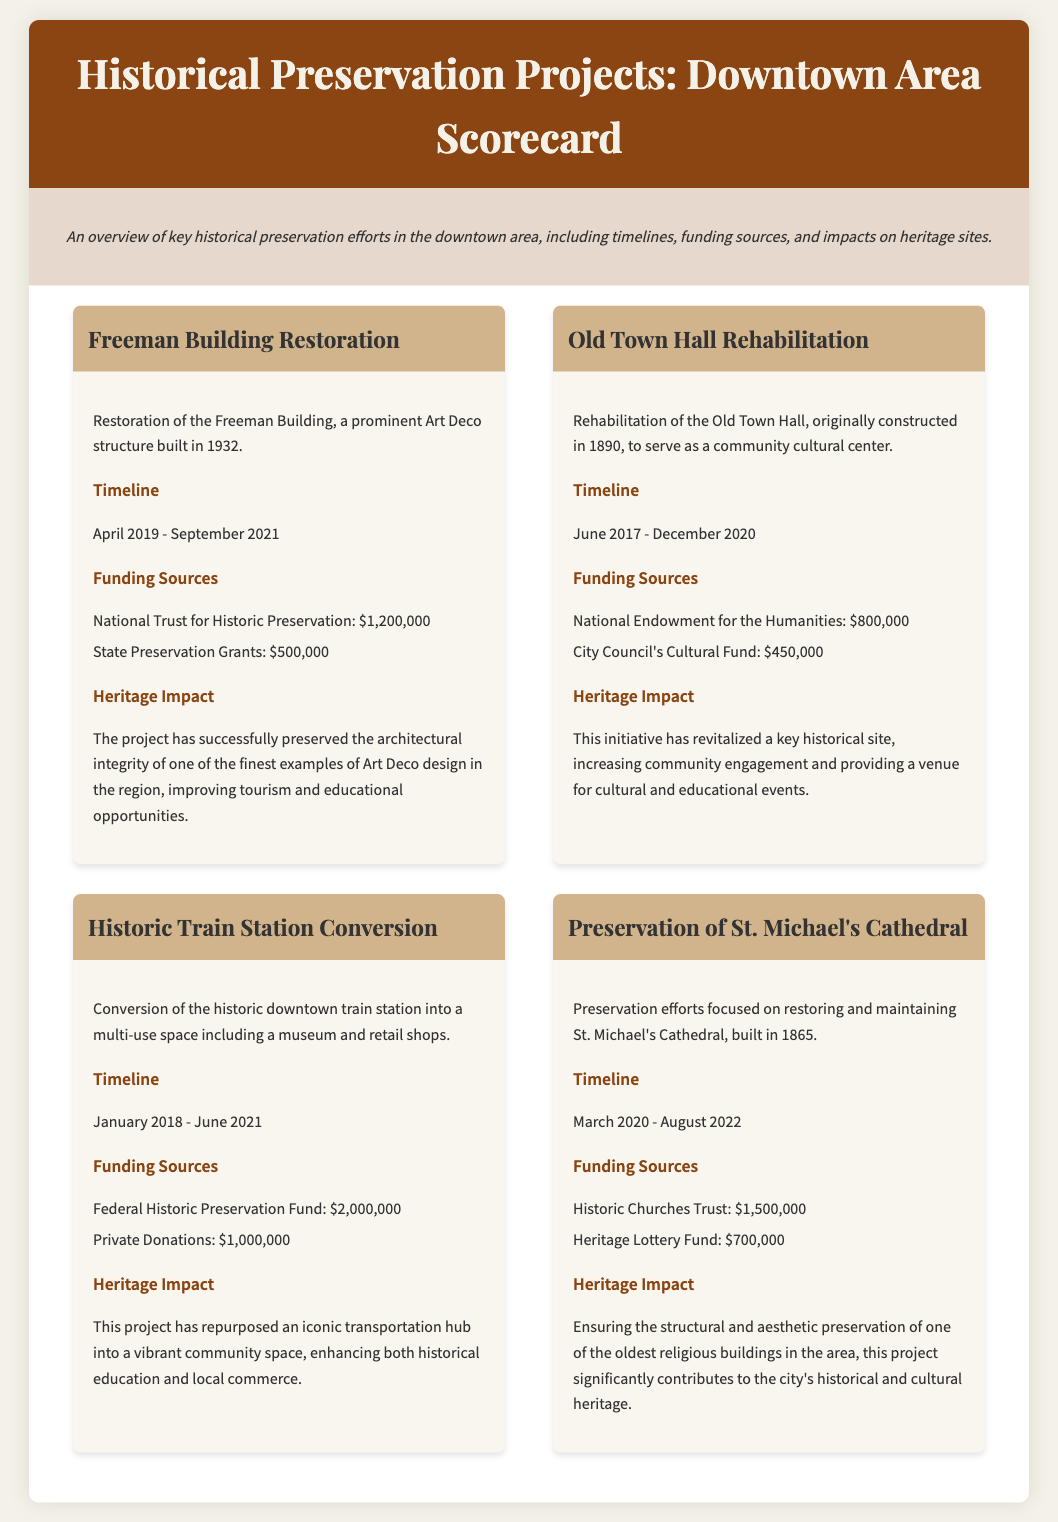What is the funding from the National Trust for Historic Preservation for the Freeman Building Restoration? The document states that the funding from the National Trust for Historic Preservation for the Freeman Building Restoration is $1,200,000.
Answer: $1,200,000 What year was the Old Town Hall originally constructed? According to the document, the Old Town Hall was originally constructed in 1890.
Answer: 1890 When did the preservation efforts for St. Michael's Cathedral start? The document indicates that the preservation efforts for St. Michael's Cathedral began in March 2020.
Answer: March 2020 What is the total funding amount for the Historic Train Station Conversion? The total funding for the Historic Train Station Conversion is the sum of Federal Historic Preservation Fund and Private Donations: $2,000,000 + $1,000,000 = $3,000,000.
Answer: $3,000,000 What heritage impact is attributed to the Old Town Hall rehabilitation? The impact states that the initiative has revitalized a key historical site, increasing community engagement and providing a venue for cultural and educational events.
Answer: Increased community engagement What structure was restored as part of the Freeman Building project? The Freeman Building project involved restoring an Art Deco structure built in 1932.
Answer: Art Deco structure Which project had a timeline that ended in 2022? The preservation of St. Michael's Cathedral had a timeline that ended in August 2022.
Answer: Preservation of St. Michael's Cathedral What type of project is the Historic Train Station Conversion? The Historic Train Station Conversion is characterized as a multi-use space including a museum and retail shops.
Answer: Multi-use space What is a unique document type-specific element included in the scorecard? The scorecard uniquely includes detailed funding sources for each preservation project listed.
Answer: Detailed funding sources 